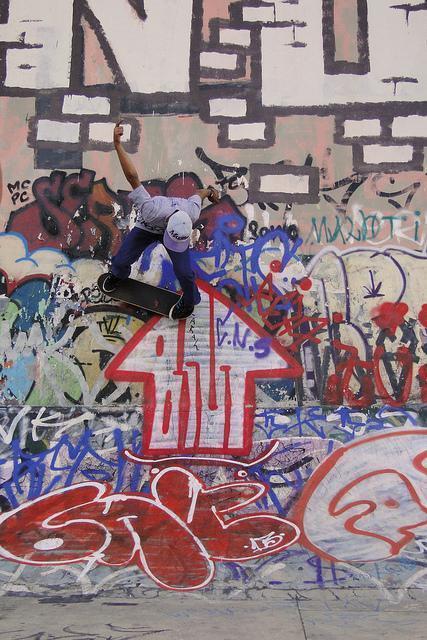How many blue airplanes are in the image?
Give a very brief answer. 0. 